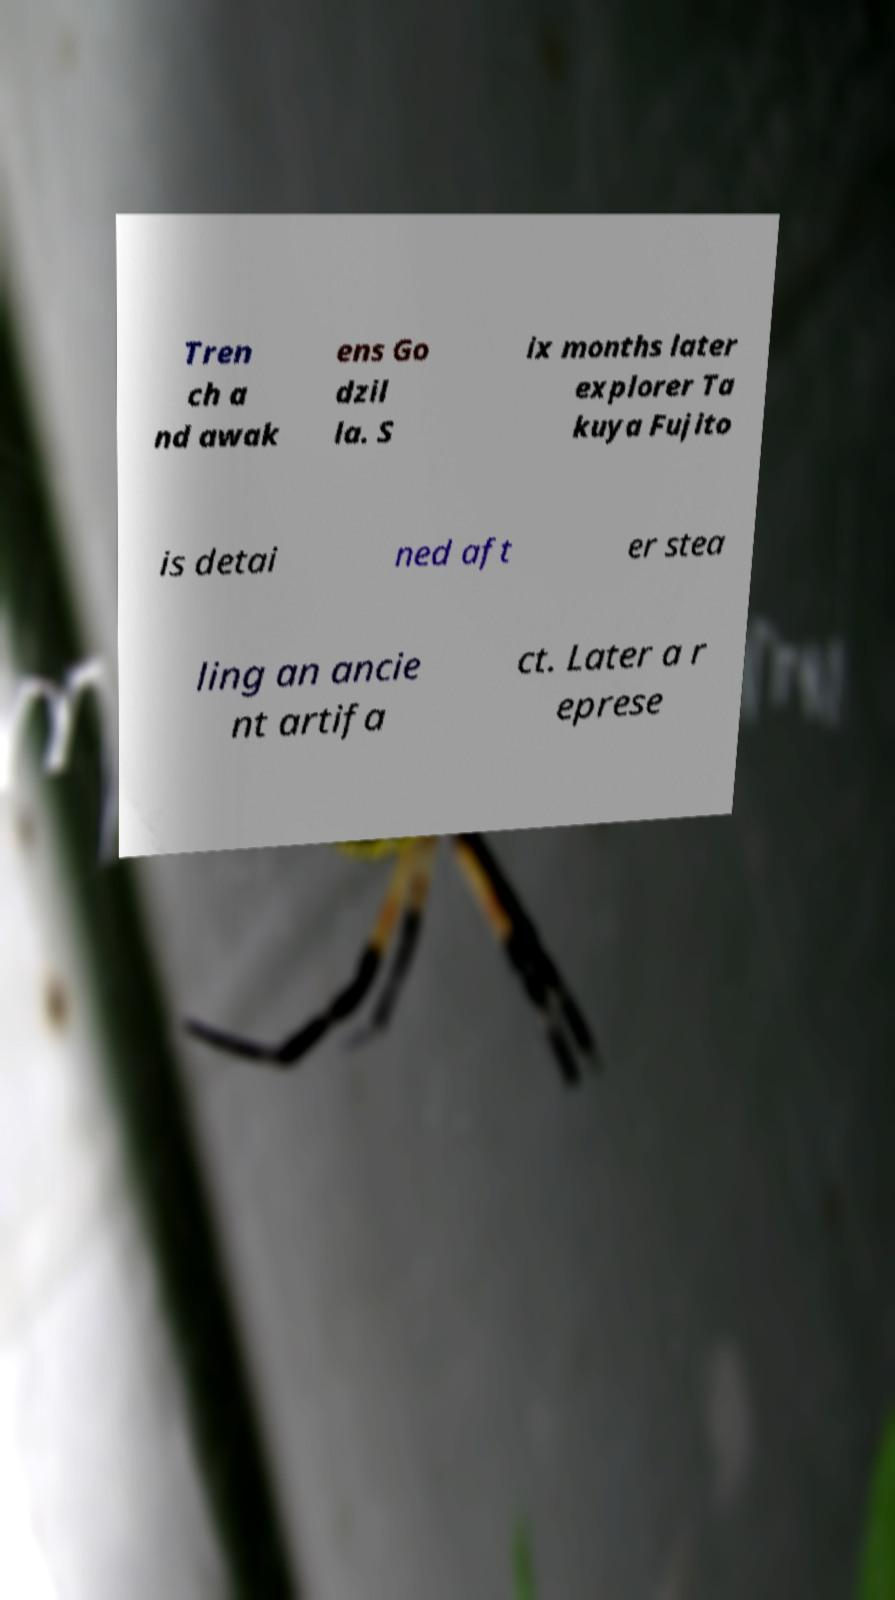For documentation purposes, I need the text within this image transcribed. Could you provide that? Tren ch a nd awak ens Go dzil la. S ix months later explorer Ta kuya Fujito is detai ned aft er stea ling an ancie nt artifa ct. Later a r eprese 